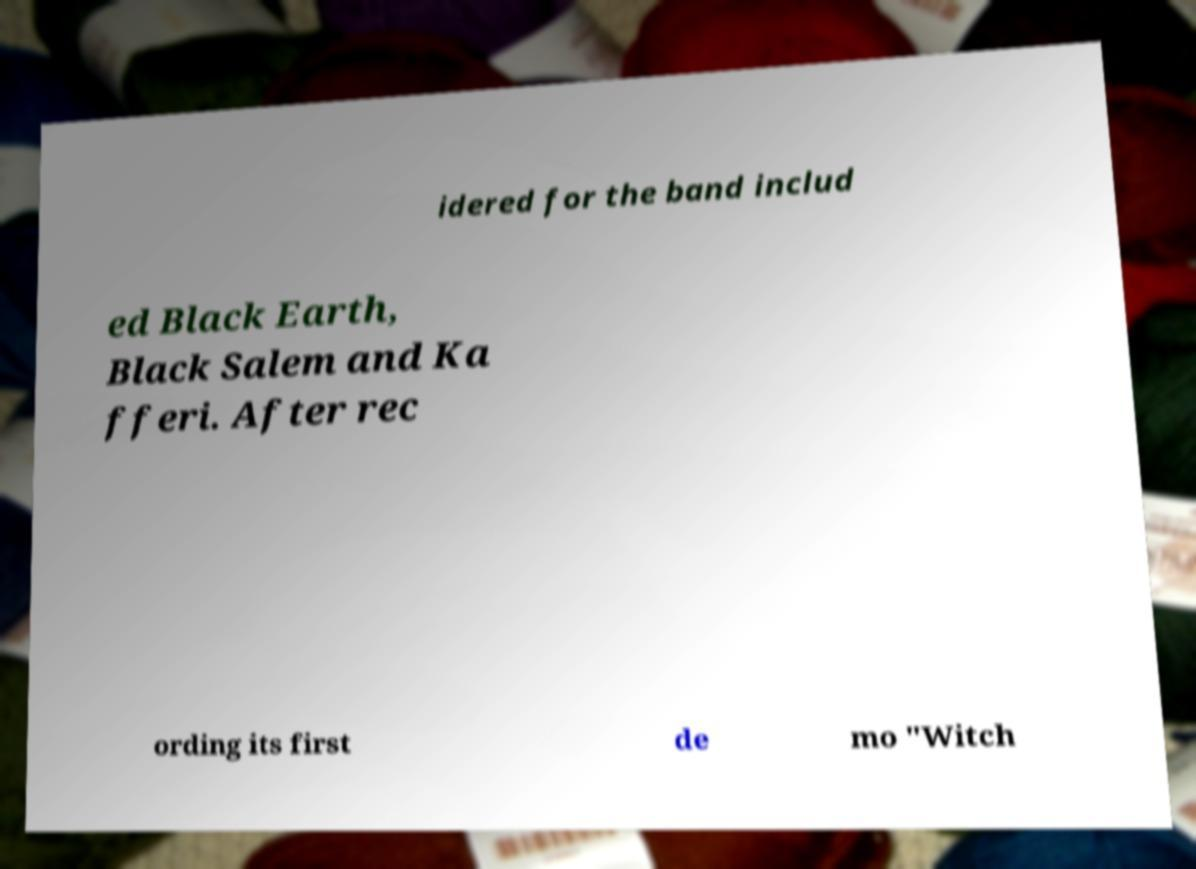There's text embedded in this image that I need extracted. Can you transcribe it verbatim? idered for the band includ ed Black Earth, Black Salem and Ka fferi. After rec ording its first de mo "Witch 